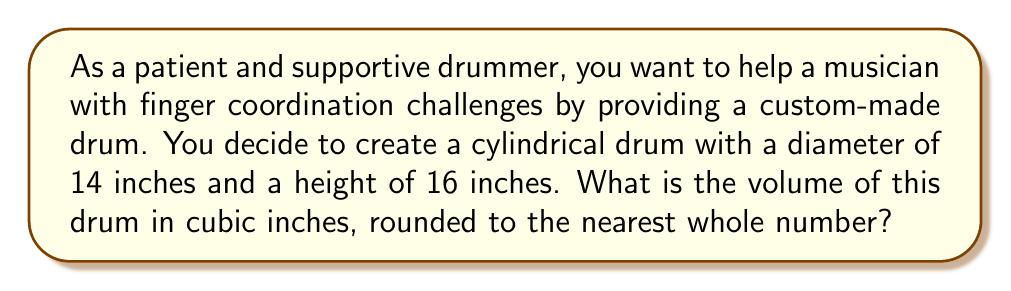Provide a solution to this math problem. To find the volume of a cylindrical drum, we need to use the formula for the volume of a cylinder:

$$V = \pi r^2 h$$

Where:
$V$ = volume
$r$ = radius of the base
$h$ = height of the cylinder

Let's break down the solution step-by-step:

1. Identify the given dimensions:
   - Diameter = 14 inches
   - Height = 16 inches

2. Calculate the radius:
   $r = \frac{\text{diameter}}{2} = \frac{14}{2} = 7$ inches

3. Substitute the values into the formula:
   $$V = \pi (7\text{ in})^2 (16\text{ in})$$

4. Calculate:
   $$V = \pi (49\text{ in}^2) (16\text{ in})$$
   $$V = 784\pi\text{ in}^3$$

5. Use 3.14159 as an approximation for $\pi$:
   $$V \approx 784 \times 3.14159\text{ in}^3$$
   $$V \approx 2463.01\text{ in}^3$$

6. Round to the nearest whole number:
   $$V \approx 2463\text{ in}^3$$

[asy]
import geometry;

size(200);
real r = 3.5;
real h = 4;

path base = circle((0,0), r);
path top = circle((0,h), r);

draw(base);
draw(top);
draw((r,0)--(r,h));
draw((-r,0)--(-r,h));
draw((0,0)--(0,h));

label("r", (r/2,0), S);
label("h", (r,h/2), E);

draw((0,0)--(r,0), arrow=Arrow(TeXHead));
draw((r,0)--(r,h), arrow=Arrow(TeXHead));
[/asy]
Answer: The volume of the cylindrical drum is approximately 2463 cubic inches. 